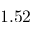Convert formula to latex. <formula><loc_0><loc_0><loc_500><loc_500>1 . 5 2</formula> 